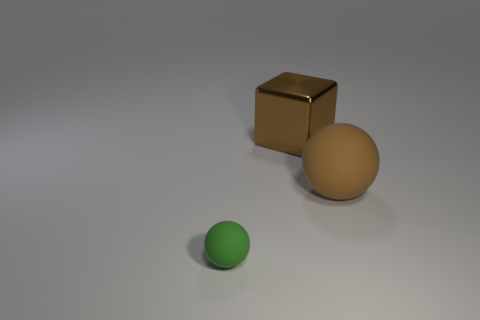The rubber ball that is the same color as the big metal block is what size?
Your response must be concise. Large. Are there any small spheres that have the same material as the large sphere?
Keep it short and to the point. Yes. What is the color of the other matte object that is the same shape as the big matte thing?
Offer a terse response. Green. Are there fewer brown things to the right of the big shiny object than large brown objects that are right of the large brown rubber thing?
Give a very brief answer. No. What number of other objects are there of the same shape as the large metal thing?
Make the answer very short. 0. Are there fewer green rubber balls behind the big block than brown metallic blocks?
Provide a short and direct response. Yes. There is a sphere behind the green thing; what is it made of?
Your response must be concise. Rubber. How many other things are the same size as the metallic object?
Your answer should be compact. 1. Are there fewer large brown metallic cubes than gray rubber cylinders?
Provide a succinct answer. No. The green object has what shape?
Provide a succinct answer. Sphere. 